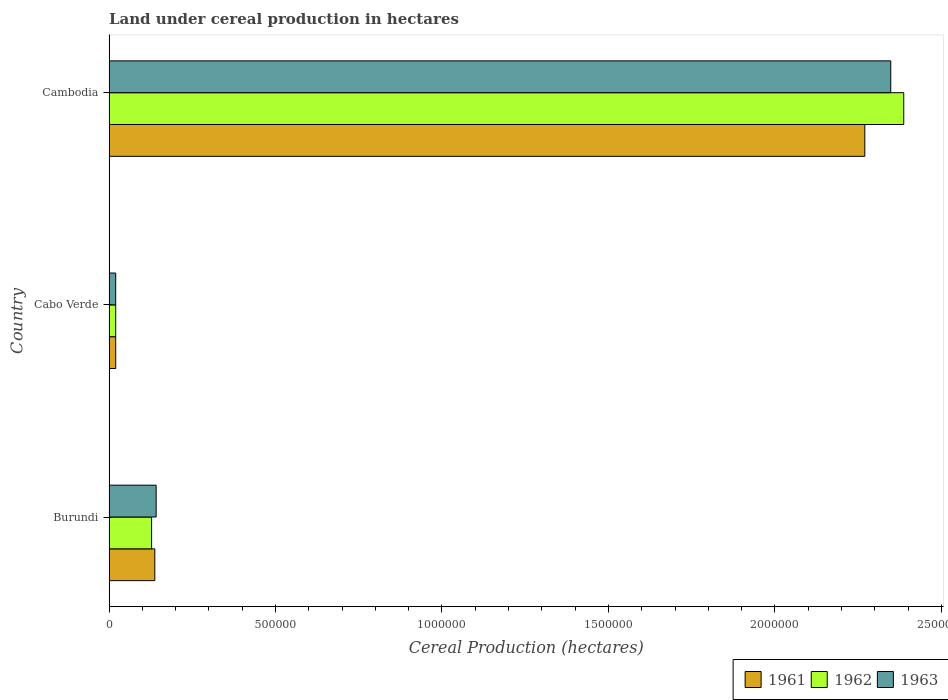How many different coloured bars are there?
Provide a short and direct response. 3. How many bars are there on the 2nd tick from the top?
Your answer should be very brief. 3. What is the label of the 3rd group of bars from the top?
Ensure brevity in your answer.  Burundi. In how many cases, is the number of bars for a given country not equal to the number of legend labels?
Offer a terse response. 0. What is the land under cereal production in 1963 in Cambodia?
Ensure brevity in your answer.  2.35e+06. Across all countries, what is the maximum land under cereal production in 1963?
Keep it short and to the point. 2.35e+06. In which country was the land under cereal production in 1963 maximum?
Provide a succinct answer. Cambodia. In which country was the land under cereal production in 1961 minimum?
Offer a very short reply. Cabo Verde. What is the total land under cereal production in 1962 in the graph?
Your answer should be compact. 2.53e+06. What is the difference between the land under cereal production in 1963 in Cabo Verde and that in Cambodia?
Provide a succinct answer. -2.33e+06. What is the difference between the land under cereal production in 1962 in Cabo Verde and the land under cereal production in 1961 in Cambodia?
Your answer should be compact. -2.25e+06. What is the average land under cereal production in 1962 per country?
Provide a succinct answer. 8.45e+05. What is the difference between the land under cereal production in 1961 and land under cereal production in 1963 in Cambodia?
Your response must be concise. -7.79e+04. What is the ratio of the land under cereal production in 1963 in Burundi to that in Cambodia?
Keep it short and to the point. 0.06. Is the land under cereal production in 1961 in Burundi less than that in Cambodia?
Offer a very short reply. Yes. Is the difference between the land under cereal production in 1961 in Burundi and Cabo Verde greater than the difference between the land under cereal production in 1963 in Burundi and Cabo Verde?
Provide a short and direct response. No. What is the difference between the highest and the second highest land under cereal production in 1962?
Keep it short and to the point. 2.26e+06. What is the difference between the highest and the lowest land under cereal production in 1961?
Your answer should be very brief. 2.25e+06. What does the 1st bar from the top in Cambodia represents?
Your answer should be very brief. 1963. Is it the case that in every country, the sum of the land under cereal production in 1961 and land under cereal production in 1963 is greater than the land under cereal production in 1962?
Provide a succinct answer. Yes. How many bars are there?
Your answer should be very brief. 9. How are the legend labels stacked?
Make the answer very short. Horizontal. What is the title of the graph?
Your answer should be compact. Land under cereal production in hectares. What is the label or title of the X-axis?
Provide a succinct answer. Cereal Production (hectares). What is the Cereal Production (hectares) of 1961 in Burundi?
Give a very brief answer. 1.37e+05. What is the Cereal Production (hectares) in 1962 in Burundi?
Offer a very short reply. 1.28e+05. What is the Cereal Production (hectares) of 1963 in Burundi?
Provide a succinct answer. 1.41e+05. What is the Cereal Production (hectares) in 1961 in Cabo Verde?
Your response must be concise. 2.00e+04. What is the Cereal Production (hectares) in 1962 in Cabo Verde?
Provide a short and direct response. 2.00e+04. What is the Cereal Production (hectares) of 1961 in Cambodia?
Give a very brief answer. 2.27e+06. What is the Cereal Production (hectares) of 1962 in Cambodia?
Your answer should be compact. 2.39e+06. What is the Cereal Production (hectares) of 1963 in Cambodia?
Make the answer very short. 2.35e+06. Across all countries, what is the maximum Cereal Production (hectares) in 1961?
Ensure brevity in your answer.  2.27e+06. Across all countries, what is the maximum Cereal Production (hectares) of 1962?
Your response must be concise. 2.39e+06. Across all countries, what is the maximum Cereal Production (hectares) of 1963?
Provide a succinct answer. 2.35e+06. Across all countries, what is the minimum Cereal Production (hectares) of 1962?
Give a very brief answer. 2.00e+04. Across all countries, what is the minimum Cereal Production (hectares) in 1963?
Ensure brevity in your answer.  2.00e+04. What is the total Cereal Production (hectares) in 1961 in the graph?
Provide a short and direct response. 2.43e+06. What is the total Cereal Production (hectares) of 1962 in the graph?
Ensure brevity in your answer.  2.53e+06. What is the total Cereal Production (hectares) of 1963 in the graph?
Give a very brief answer. 2.51e+06. What is the difference between the Cereal Production (hectares) of 1961 in Burundi and that in Cabo Verde?
Keep it short and to the point. 1.17e+05. What is the difference between the Cereal Production (hectares) of 1962 in Burundi and that in Cabo Verde?
Your answer should be very brief. 1.08e+05. What is the difference between the Cereal Production (hectares) in 1963 in Burundi and that in Cabo Verde?
Make the answer very short. 1.21e+05. What is the difference between the Cereal Production (hectares) of 1961 in Burundi and that in Cambodia?
Provide a short and direct response. -2.13e+06. What is the difference between the Cereal Production (hectares) in 1962 in Burundi and that in Cambodia?
Make the answer very short. -2.26e+06. What is the difference between the Cereal Production (hectares) of 1963 in Burundi and that in Cambodia?
Keep it short and to the point. -2.21e+06. What is the difference between the Cereal Production (hectares) of 1961 in Cabo Verde and that in Cambodia?
Your answer should be very brief. -2.25e+06. What is the difference between the Cereal Production (hectares) in 1962 in Cabo Verde and that in Cambodia?
Offer a very short reply. -2.37e+06. What is the difference between the Cereal Production (hectares) of 1963 in Cabo Verde and that in Cambodia?
Provide a short and direct response. -2.33e+06. What is the difference between the Cereal Production (hectares) of 1961 in Burundi and the Cereal Production (hectares) of 1962 in Cabo Verde?
Offer a very short reply. 1.17e+05. What is the difference between the Cereal Production (hectares) of 1961 in Burundi and the Cereal Production (hectares) of 1963 in Cabo Verde?
Your answer should be compact. 1.17e+05. What is the difference between the Cereal Production (hectares) of 1962 in Burundi and the Cereal Production (hectares) of 1963 in Cabo Verde?
Provide a short and direct response. 1.08e+05. What is the difference between the Cereal Production (hectares) of 1961 in Burundi and the Cereal Production (hectares) of 1962 in Cambodia?
Your response must be concise. -2.25e+06. What is the difference between the Cereal Production (hectares) of 1961 in Burundi and the Cereal Production (hectares) of 1963 in Cambodia?
Ensure brevity in your answer.  -2.21e+06. What is the difference between the Cereal Production (hectares) in 1962 in Burundi and the Cereal Production (hectares) in 1963 in Cambodia?
Give a very brief answer. -2.22e+06. What is the difference between the Cereal Production (hectares) in 1961 in Cabo Verde and the Cereal Production (hectares) in 1962 in Cambodia?
Offer a terse response. -2.37e+06. What is the difference between the Cereal Production (hectares) in 1961 in Cabo Verde and the Cereal Production (hectares) in 1963 in Cambodia?
Make the answer very short. -2.33e+06. What is the difference between the Cereal Production (hectares) in 1962 in Cabo Verde and the Cereal Production (hectares) in 1963 in Cambodia?
Keep it short and to the point. -2.33e+06. What is the average Cereal Production (hectares) of 1961 per country?
Ensure brevity in your answer.  8.09e+05. What is the average Cereal Production (hectares) in 1962 per country?
Provide a short and direct response. 8.45e+05. What is the average Cereal Production (hectares) of 1963 per country?
Offer a very short reply. 8.36e+05. What is the difference between the Cereal Production (hectares) in 1961 and Cereal Production (hectares) in 1962 in Burundi?
Keep it short and to the point. 9597. What is the difference between the Cereal Production (hectares) of 1961 and Cereal Production (hectares) of 1963 in Burundi?
Ensure brevity in your answer.  -4063. What is the difference between the Cereal Production (hectares) in 1962 and Cereal Production (hectares) in 1963 in Burundi?
Offer a terse response. -1.37e+04. What is the difference between the Cereal Production (hectares) in 1961 and Cereal Production (hectares) in 1962 in Cabo Verde?
Offer a very short reply. 0. What is the difference between the Cereal Production (hectares) of 1961 and Cereal Production (hectares) of 1963 in Cabo Verde?
Your answer should be very brief. 0. What is the difference between the Cereal Production (hectares) in 1961 and Cereal Production (hectares) in 1962 in Cambodia?
Give a very brief answer. -1.17e+05. What is the difference between the Cereal Production (hectares) in 1961 and Cereal Production (hectares) in 1963 in Cambodia?
Give a very brief answer. -7.79e+04. What is the difference between the Cereal Production (hectares) of 1962 and Cereal Production (hectares) of 1963 in Cambodia?
Provide a succinct answer. 3.91e+04. What is the ratio of the Cereal Production (hectares) of 1961 in Burundi to that in Cabo Verde?
Give a very brief answer. 6.87. What is the ratio of the Cereal Production (hectares) of 1962 in Burundi to that in Cabo Verde?
Make the answer very short. 6.39. What is the ratio of the Cereal Production (hectares) in 1963 in Burundi to that in Cabo Verde?
Your answer should be very brief. 7.07. What is the ratio of the Cereal Production (hectares) in 1961 in Burundi to that in Cambodia?
Keep it short and to the point. 0.06. What is the ratio of the Cereal Production (hectares) of 1962 in Burundi to that in Cambodia?
Your response must be concise. 0.05. What is the ratio of the Cereal Production (hectares) of 1963 in Burundi to that in Cambodia?
Your answer should be very brief. 0.06. What is the ratio of the Cereal Production (hectares) of 1961 in Cabo Verde to that in Cambodia?
Your response must be concise. 0.01. What is the ratio of the Cereal Production (hectares) of 1962 in Cabo Verde to that in Cambodia?
Provide a short and direct response. 0.01. What is the ratio of the Cereal Production (hectares) in 1963 in Cabo Verde to that in Cambodia?
Keep it short and to the point. 0.01. What is the difference between the highest and the second highest Cereal Production (hectares) of 1961?
Ensure brevity in your answer.  2.13e+06. What is the difference between the highest and the second highest Cereal Production (hectares) of 1962?
Keep it short and to the point. 2.26e+06. What is the difference between the highest and the second highest Cereal Production (hectares) of 1963?
Provide a succinct answer. 2.21e+06. What is the difference between the highest and the lowest Cereal Production (hectares) in 1961?
Ensure brevity in your answer.  2.25e+06. What is the difference between the highest and the lowest Cereal Production (hectares) in 1962?
Make the answer very short. 2.37e+06. What is the difference between the highest and the lowest Cereal Production (hectares) of 1963?
Ensure brevity in your answer.  2.33e+06. 